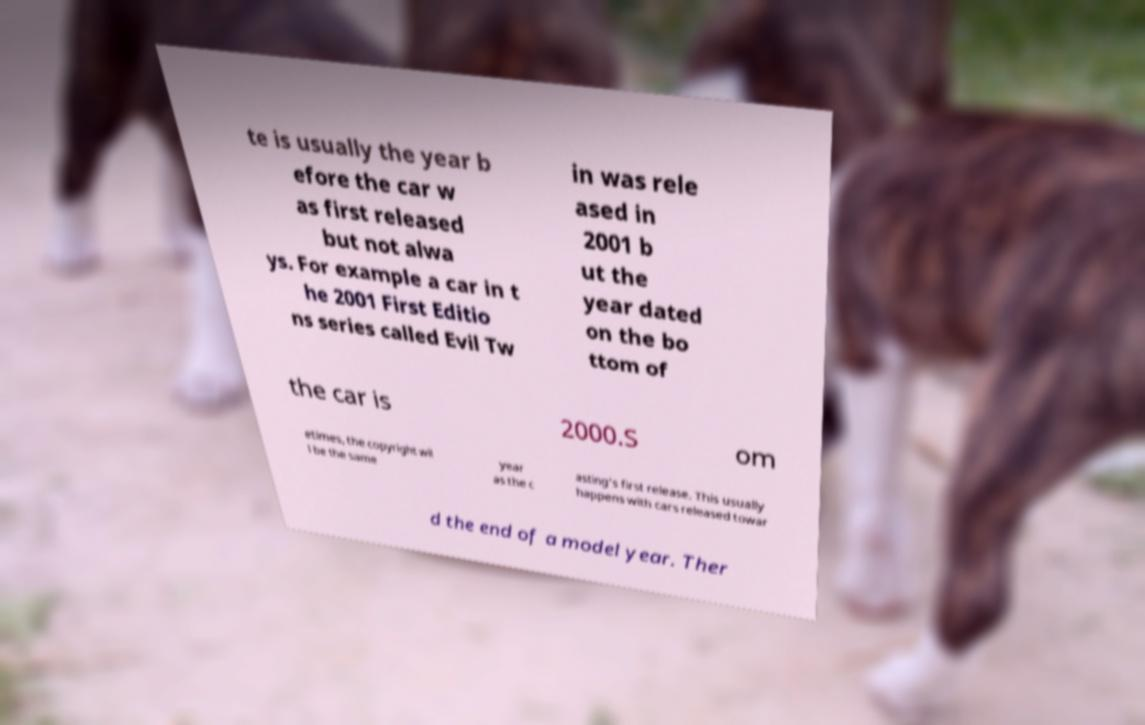What messages or text are displayed in this image? I need them in a readable, typed format. te is usually the year b efore the car w as first released but not alwa ys. For example a car in t he 2001 First Editio ns series called Evil Tw in was rele ased in 2001 b ut the year dated on the bo ttom of the car is 2000.S om etimes, the copyright wil l be the same year as the c asting's first release. This usually happens with cars released towar d the end of a model year. Ther 